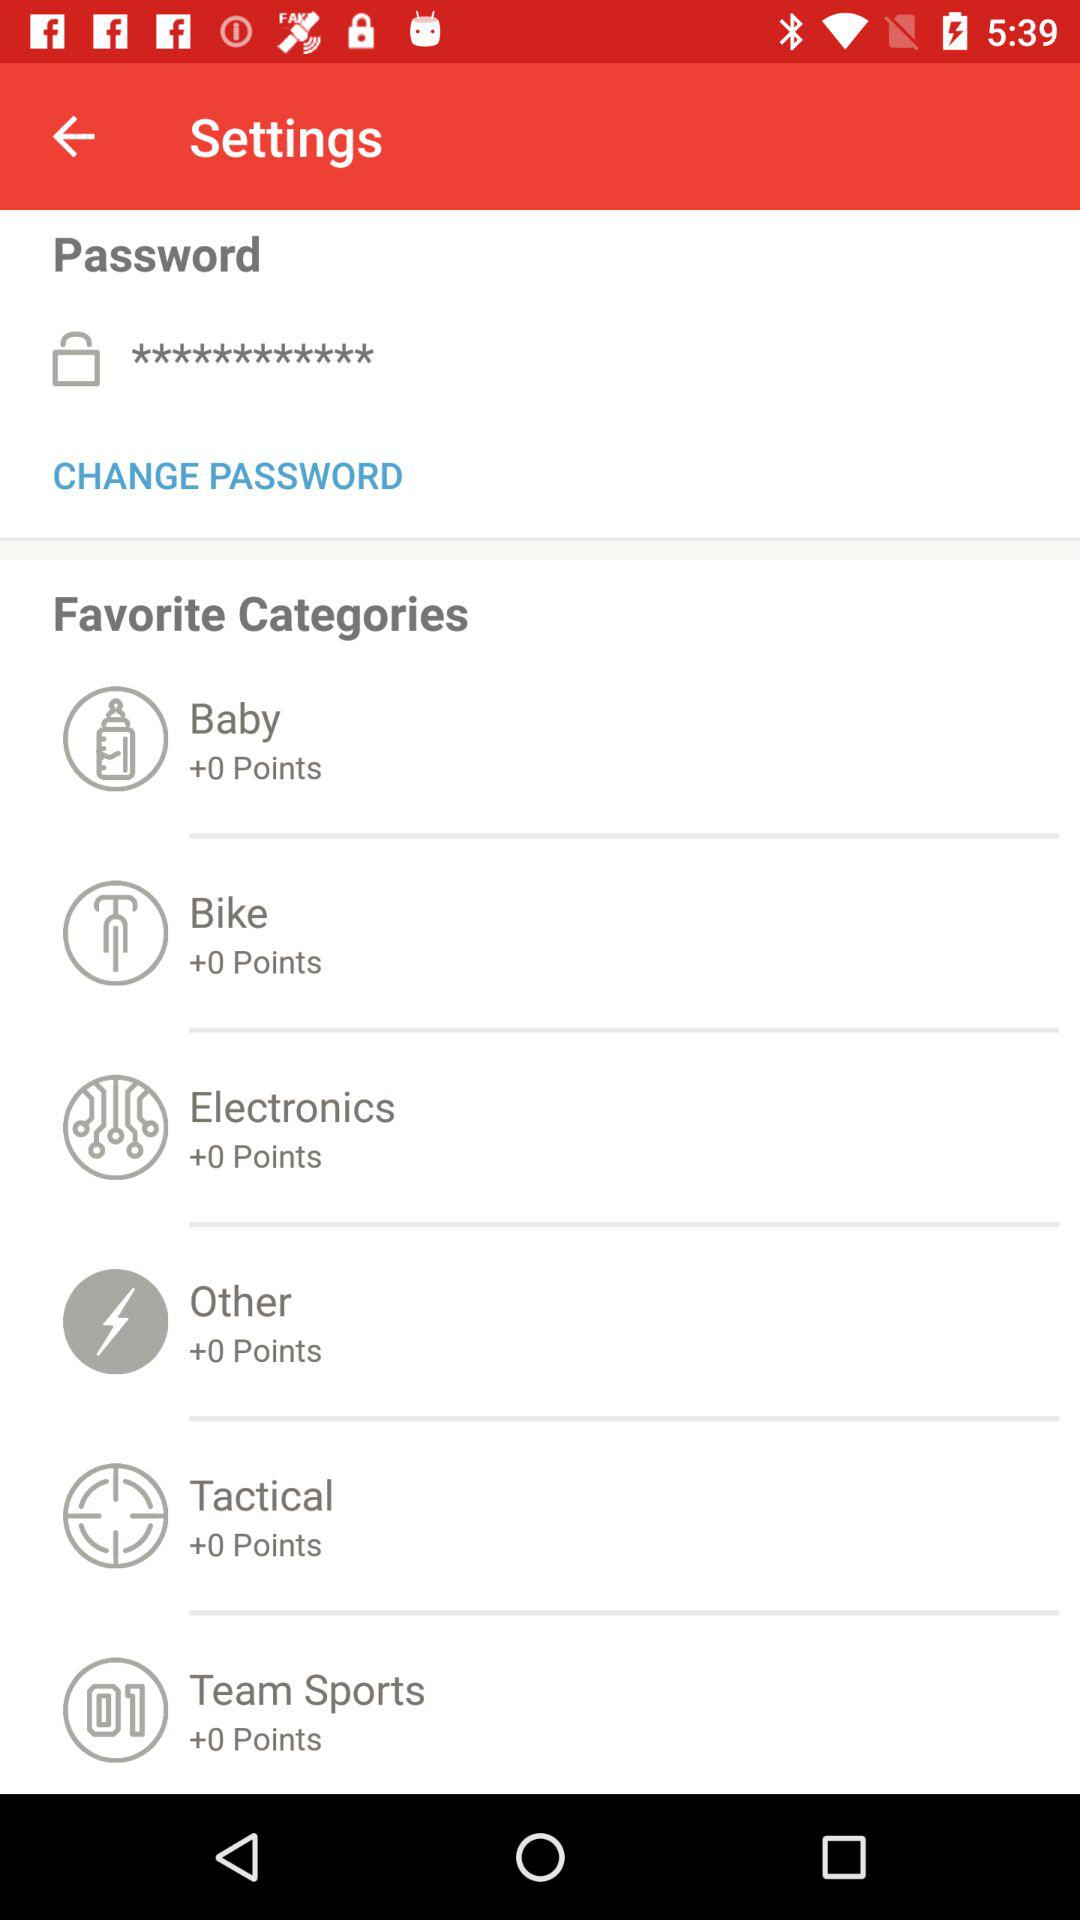What are the points for "Baby"? The points for "Baby" are 0. 